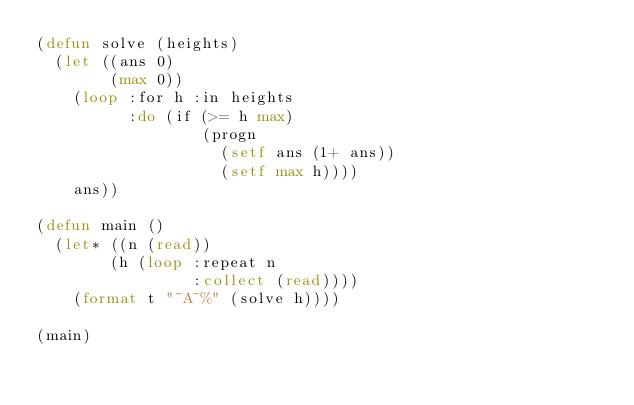<code> <loc_0><loc_0><loc_500><loc_500><_Lisp_>(defun solve (heights)
  (let ((ans 0)
        (max 0))
    (loop :for h :in heights
          :do (if (>= h max)
                  (progn
                    (setf ans (1+ ans))
                    (setf max h))))
    ans))

(defun main ()
  (let* ((n (read))
        (h (loop :repeat n
                 :collect (read))))
    (format t "~A~%" (solve h))))

(main)
</code> 